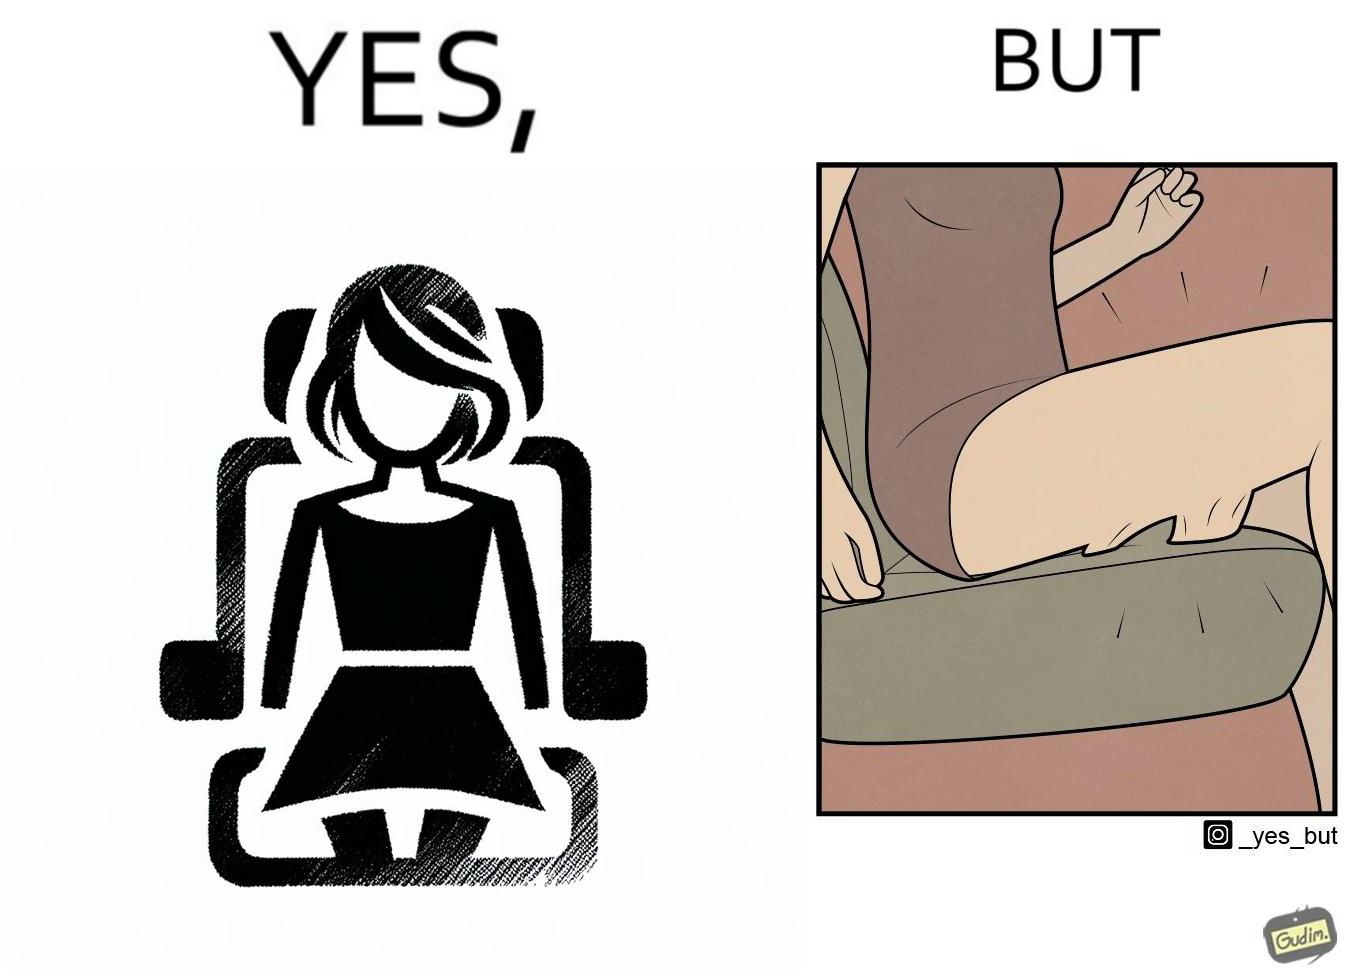Describe the contrast between the left and right parts of this image. In the left part of the image: a woman wearing a short dress sitting on the co-passengers seat in a car In the right part of the image: skin of a woman getting sticked to the seat fabric of the car, causing inconvenience 